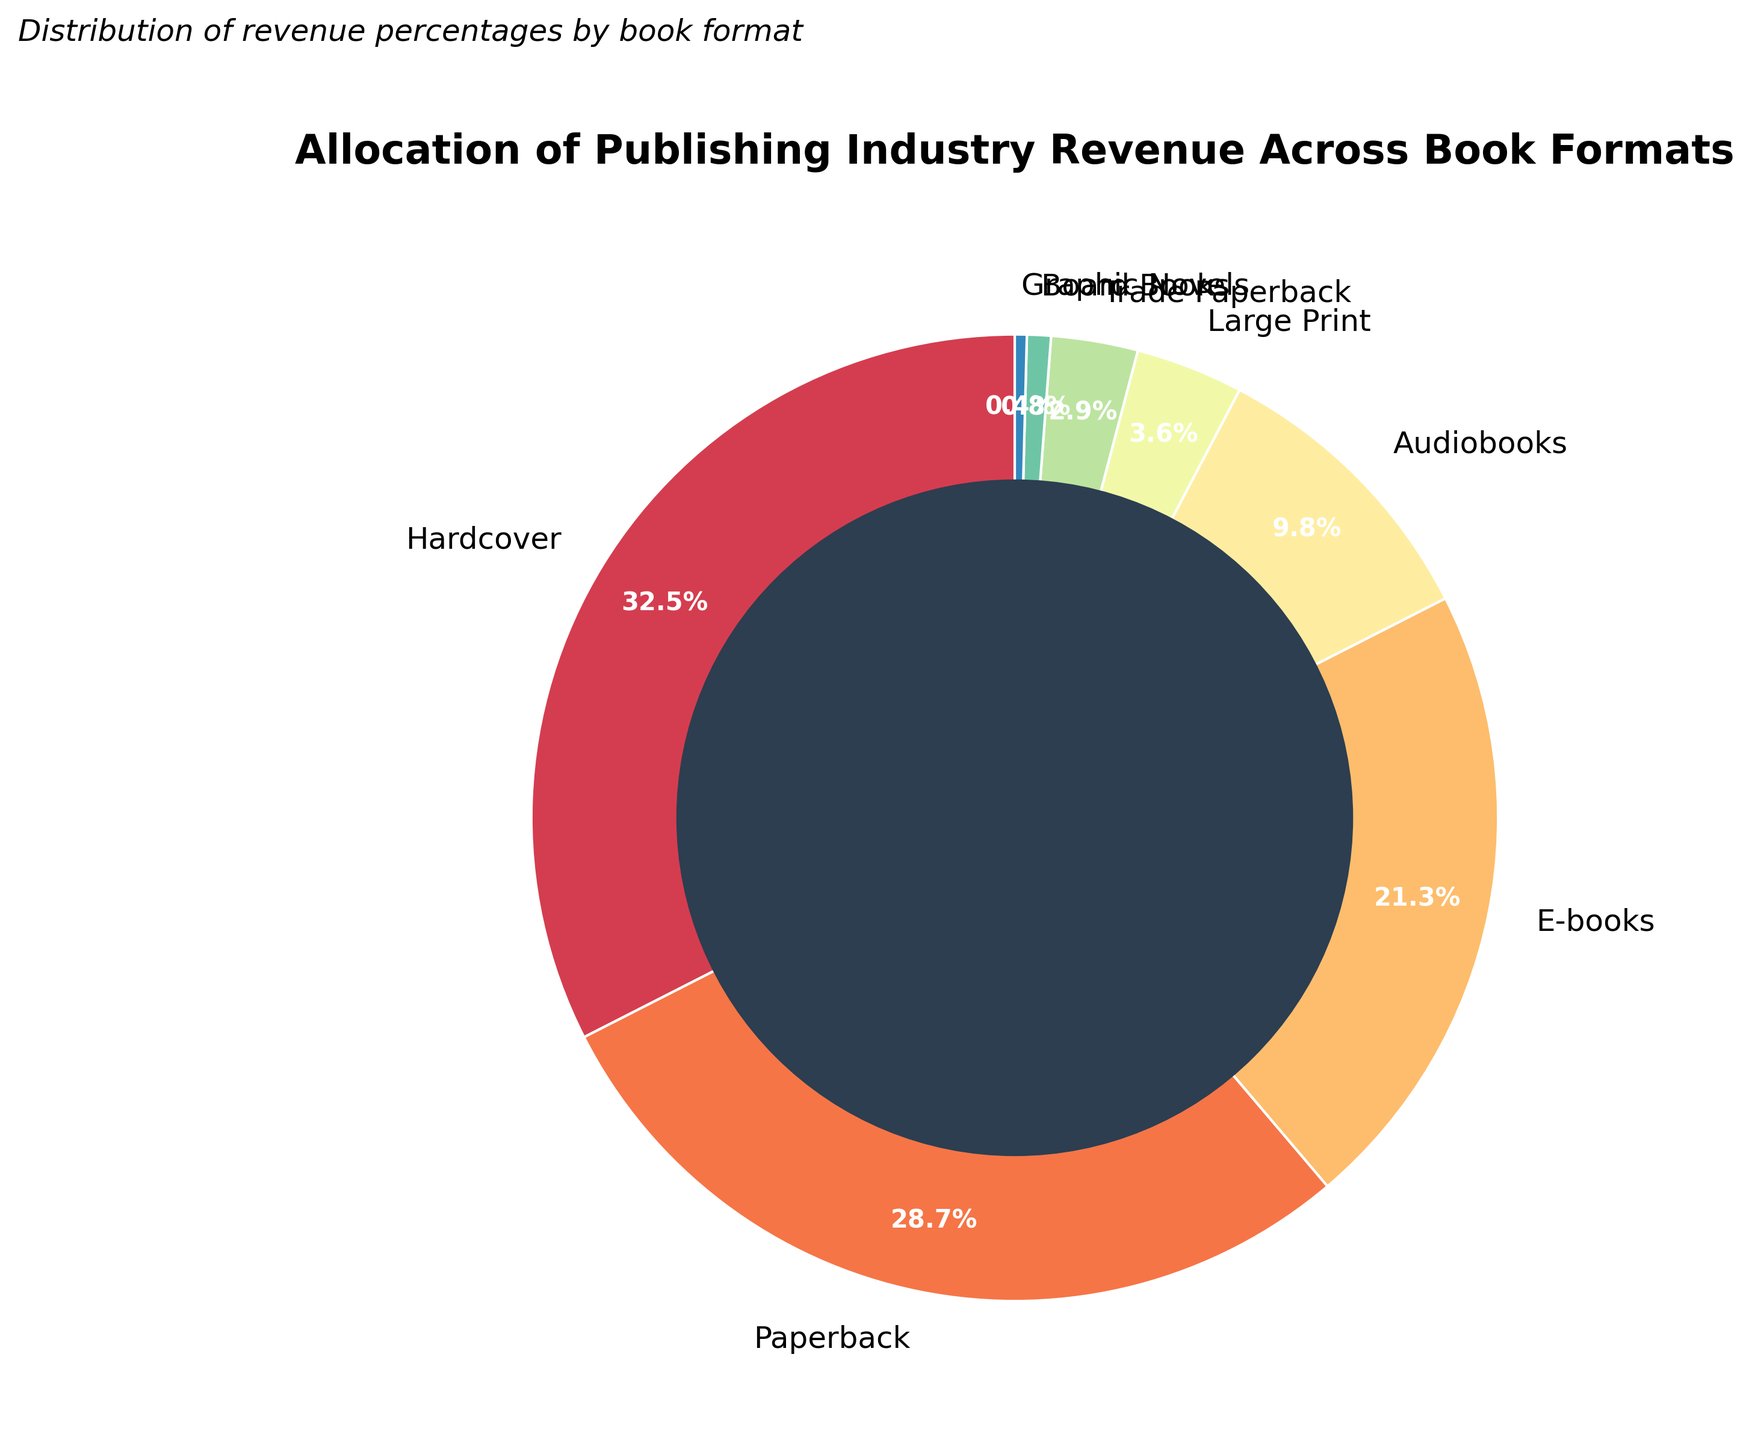What percentage of the publishing industry's revenue is generated by hardcover and paperback formats combined? Sum the percentages for hardcover (32.5%) and paperback (28.7%) to find the combined percentage. 32.5 + 28.7 = 61.2
Answer: 61.2% Which book format accounts for the smallest percentage of revenue? Identify the format with the lowest percentage value. Graphic novels have the lowest at 0.4%.
Answer: Graphic Novels How much more revenue does the hardcover format generate compared to the audiobooks format? Subtract the percentage of audiobooks (9.8%) from the percentage of hardcovers (32.5%). 32.5 - 9.8 = 22.7
Answer: 22.7% Are there more book formats that generate less than 5% of the revenue, or more than 20%? Count the number of formats: less than 5% (Large Print, Trade Paperback, Board Books, Graphic Novels) is 4; more than 20% (Hardcover, Paperback, E-books) is 3.
Answer: Less than 5% What is the color used to represent the e-books format? Visually identify the wedge associated with e-books and describe its color. It is located on the pie chart with a distinct color.
Answer: (provide visual color, e.g., yellowish-brown) How does the revenue percentage for trade paperbacks compare to that for large print? Compare percentages: Trade Paperbacks are at 2.9% and Large Print at 3.6%. Trade Paperbacks have a lower revenue percentage than Large Print.
Answer: Less than Estimate the average revenue percentage of formats that contribute less than 10% each to the total revenue. Sum the percentages for formats under 10% (Audiobooks, Large Print, Trade Paperback, Board Books, Graphic Novels): 9.8 + 3.6 + 2.9 + 0.8 + 0.4 = 17.5. There are 5 such formats; divide the sum by 5. 17.5/5 = 3.5
Answer: 3.5% Which two formats together nearly equate to the revenue percentage of the e-books format? Identify the format pairs whose summed percentages are close to 21.3%. Audiobooks (9.8%) and Large Print (3.6%) approximate to 13.4%. Instead, Paperbacks (28.7%) and subtract difference closer.
Answer: Not directly possible; closest is Paperbacks alone What are the percentages of the four largest contributors to the industry revenue? Identify the top four slices by percentage: Hardcover (32.5%), Paperback (28.7%), E-books (21.3%), and Audiobooks (9.8%).
Answer: 32.5%, 28.7%, 21.3%, 9.8% By visual observation, which format generates slightly more revenue: Board Books or Graphic Novels? Compare the sizes of the wedges for Board Books and Graphic Novels. Board Books hold 0.8% while Graphic Novels hold 0.4%.
Answer: Board Books 